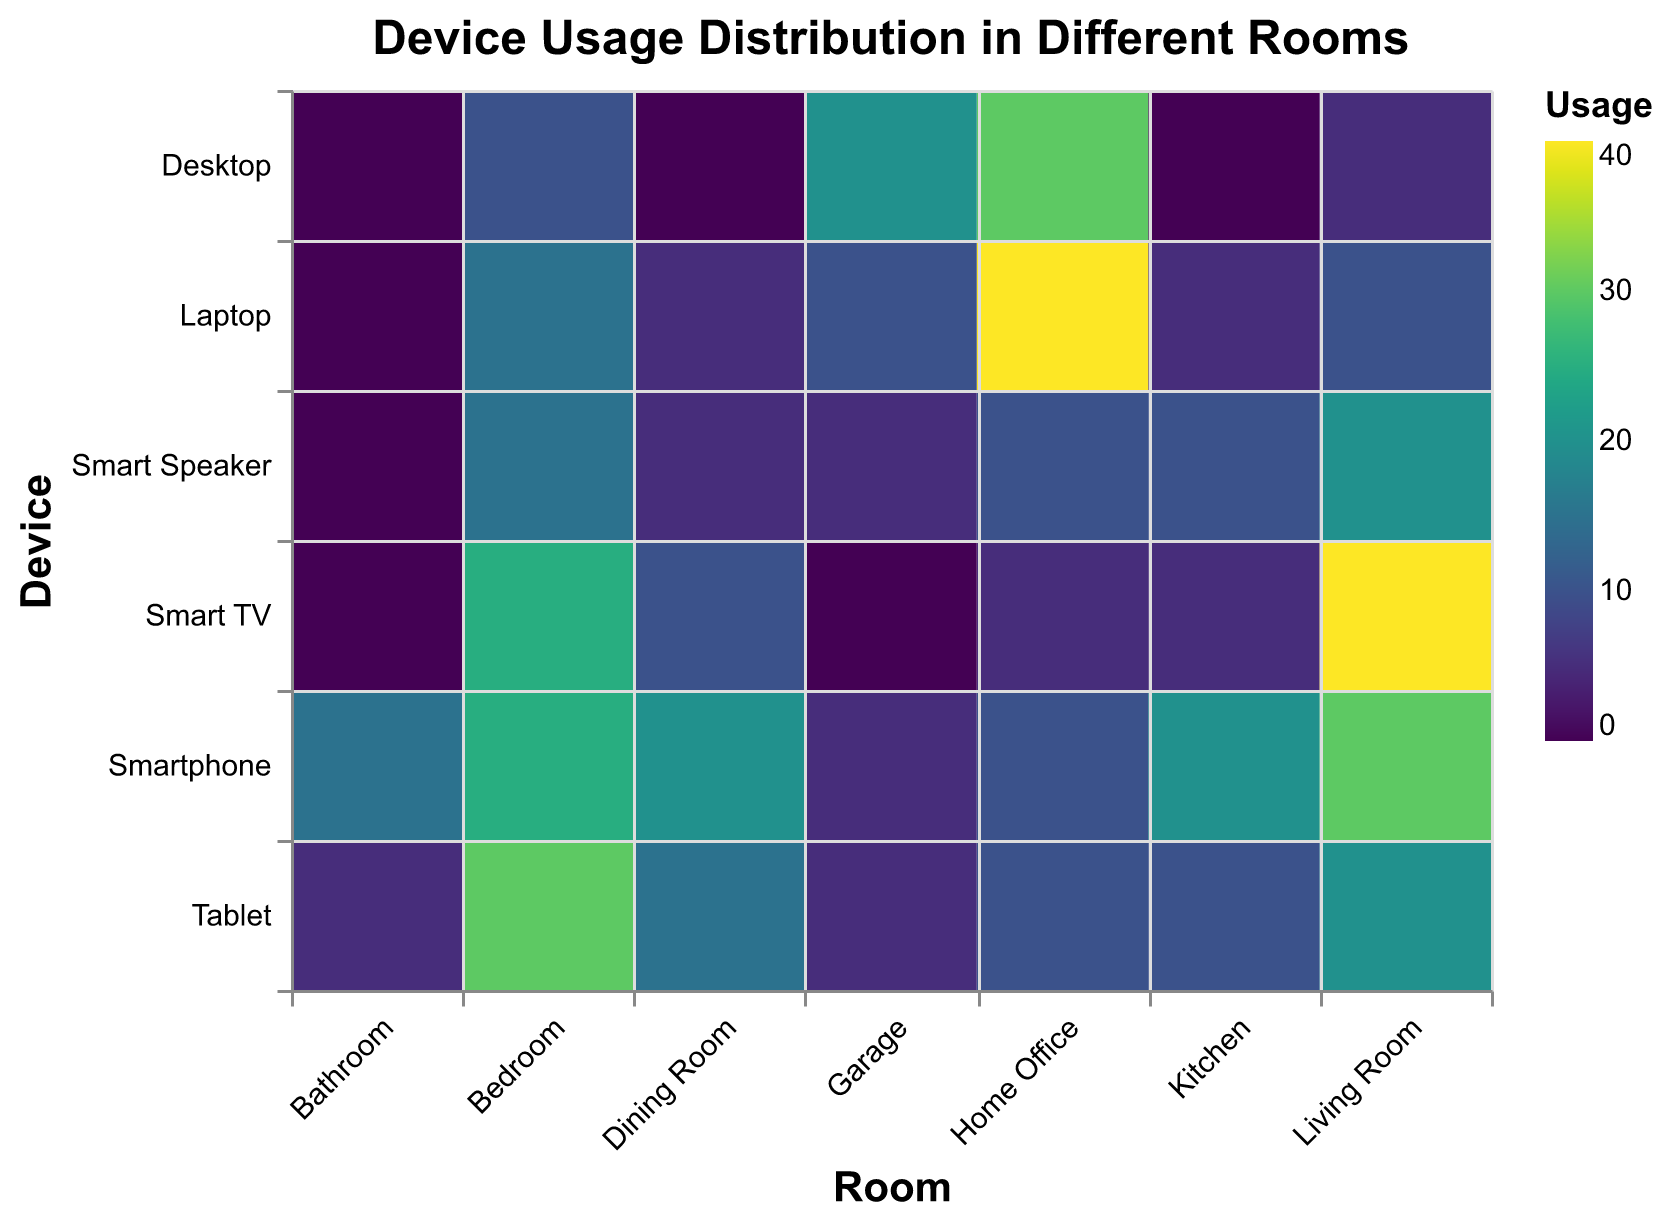What's the most used device in the Living Room? Look at the column for the Living Room. The highest usage value is for the Smart TV, which has a usage of 40.
Answer: Smart TV Which room has the highest usage of laptops? Look at the row for the Laptop. The highest usage value is in the Home Office, which has a usage of 40.
Answer: Home Office What's the total device usage in the Kitchen? Sum up all the usage values in the Kitchen column: 20 (Smartphone) + 5 (Laptop) + 10 (Tablet) + 5 (Smart TV) + 10 (Smart Speaker) + 0 (Desktop) = 50.
Answer: 50 Which device has zero usage in the Bathroom? Look at the Bathroom column and find the devices with zero usage: Laptop, Smart TV, Smart Speaker, and Desktop.
Answer: Laptop, Smart TV, Smart Speaker, Desktop Which room has more usage of smart speakers: Kitchen or Dining Room? Compare the usage values in the Kitchen and Dining Room for Smart Speakers. The Kitchen has a usage of 10, and the Dining Room has a usage of 5. 10 > 5.
Answer: Kitchen Combining Smartphone and Tablet, which room has the highest combined usage? Add the usage values for Smartphone and Tablet in each room and find the highest sum. 
Living Room: 30 + 20 = 50
Kitchen: 20 + 10 = 30
Bedroom: 25 + 30 = 55
Home Office: 10 + 10 = 20
Bathroom: 15 + 5 = 20
Dining Room: 20 + 15 = 35
Garage: 5 + 5 = 10
The Bedroom has the highest combined usage with 55.
Answer: Bedroom How does the Desktop usage in the Garage compare to its usage in the Bedroom? Compare the Desktop usage values in the Garage (20) and the Bedroom (10). 20 > 10.
Answer: Higher What is the least used device in the Home Office? Look at the Home Office column and find the device with the lowest usage value. The lowest usage value is 5, which applies to Smart TV.
Answer: Smart TV What’s the difference in Smart TV usage between the Living Room and Bedroom? Subtract the Smart TV usage value in the Bedroom (25) from that in the Living Room (40). 40 - 25 = 15.
Answer: 15 Which room has the least usage of devices overall? Calculate the total usage for each room:
Living Room: 30 + 10 + 20 + 40 + 20 + 5 = 125
Kitchen: 20 + 5 + 10 + 5 + 10 + 0 = 50
Bedroom: 25 + 15 + 30 + 25 + 15 + 10 = 120
Home Office: 10 + 40 + 10 + 5 + 10 + 30 = 105
Bathroom: 15 + 0 + 5 + 0 + 0 + 0 = 20
Dining Room: 20 + 5 + 15 + 10 + 5 + 0 = 55
Garage: 5 + 10 + 5 + 0 + 5 + 20 = 45
The Bathroom has the least overall usage with 20.
Answer: Bathroom 